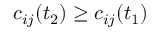Convert formula to latex. <formula><loc_0><loc_0><loc_500><loc_500>c _ { i j } ( t _ { 2 } ) \geq c _ { i j } ( t _ { 1 } )</formula> 